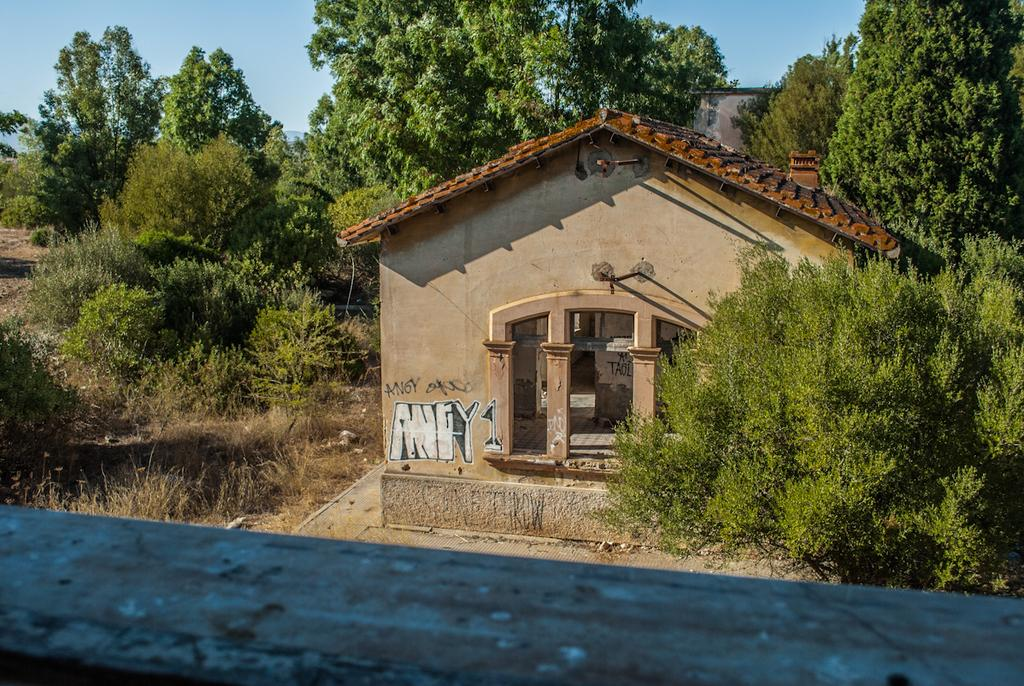What is the main subject in the middle of the image? There is a house in the middle of the image. What can be seen in the background of the image? There are trees in the background of the image. What is visible at the top of the image? The sky is visible at the top of the image. Where are the kittens playing in the image? There are no kittens present in the image. What type of coach is parked near the house in the image? There is no coach present in the image. 